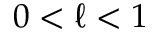Convert formula to latex. <formula><loc_0><loc_0><loc_500><loc_500>0 < \ell < 1</formula> 